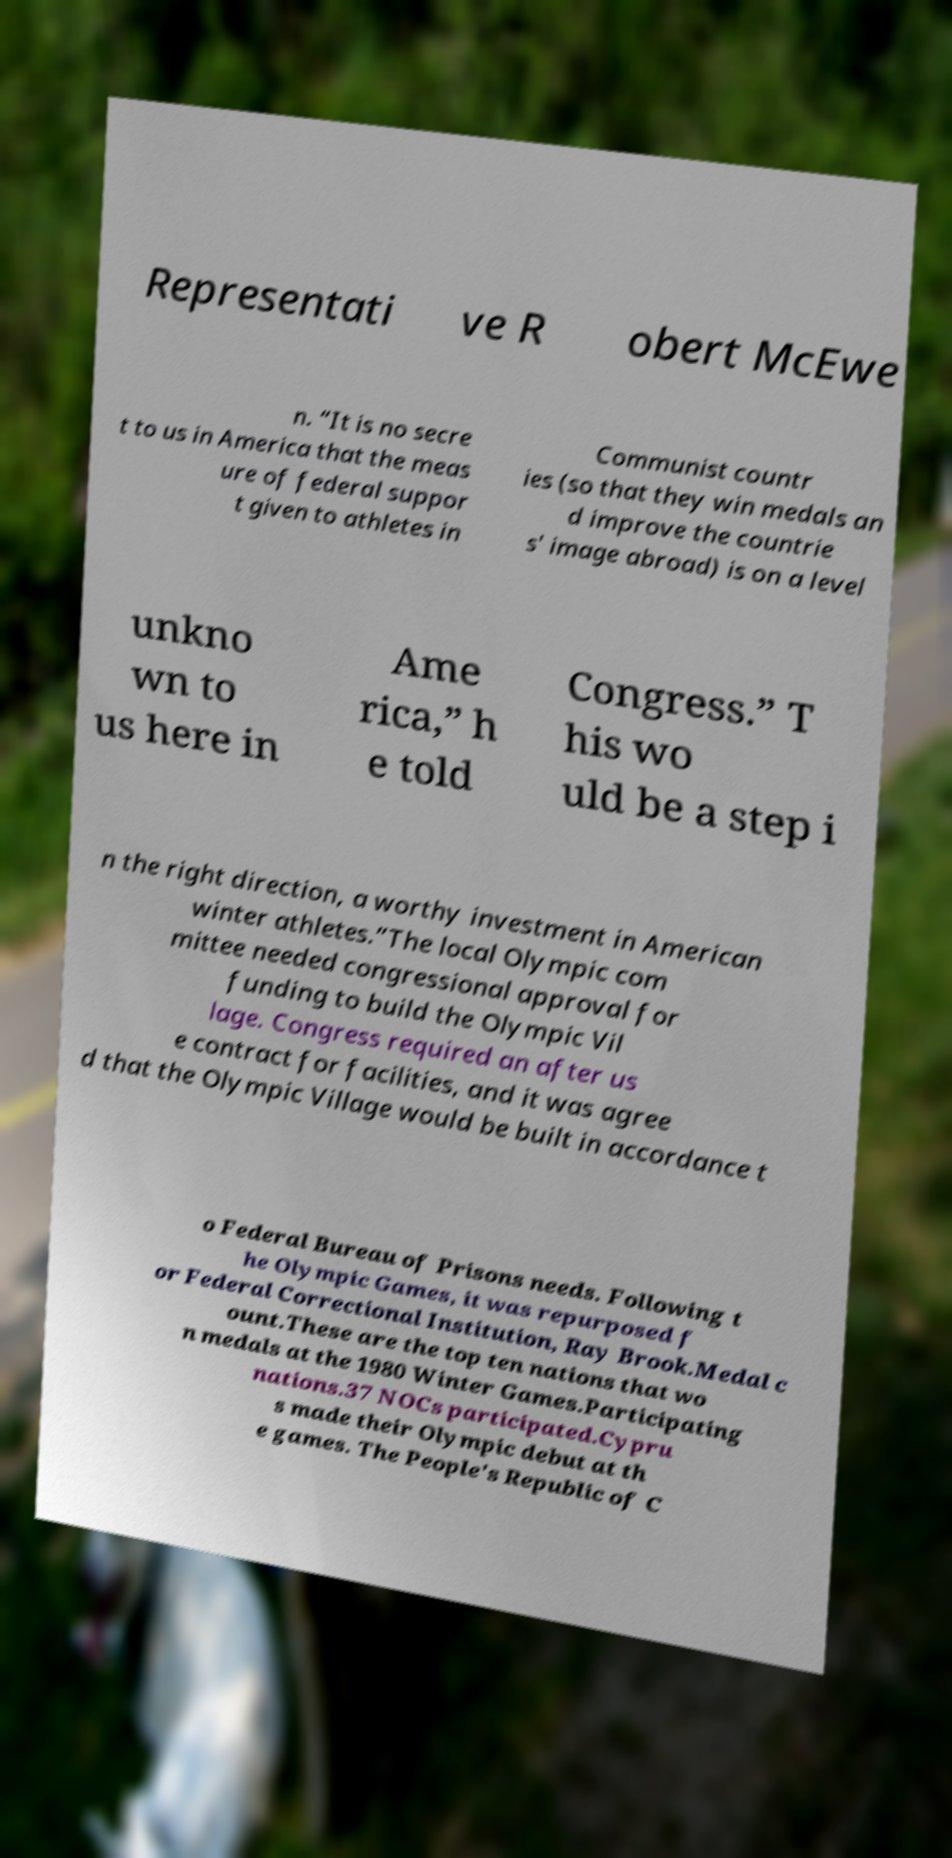Please read and relay the text visible in this image. What does it say? Representati ve R obert McEwe n. “It is no secre t to us in America that the meas ure of federal suppor t given to athletes in Communist countr ies (so that they win medals an d improve the countrie s' image abroad) is on a level unkno wn to us here in Ame rica,” h e told Congress.” T his wo uld be a step i n the right direction, a worthy investment in American winter athletes.”The local Olympic com mittee needed congressional approval for funding to build the Olympic Vil lage. Congress required an after us e contract for facilities, and it was agree d that the Olympic Village would be built in accordance t o Federal Bureau of Prisons needs. Following t he Olympic Games, it was repurposed f or Federal Correctional Institution, Ray Brook.Medal c ount.These are the top ten nations that wo n medals at the 1980 Winter Games.Participating nations.37 NOCs participated.Cypru s made their Olympic debut at th e games. The People's Republic of C 